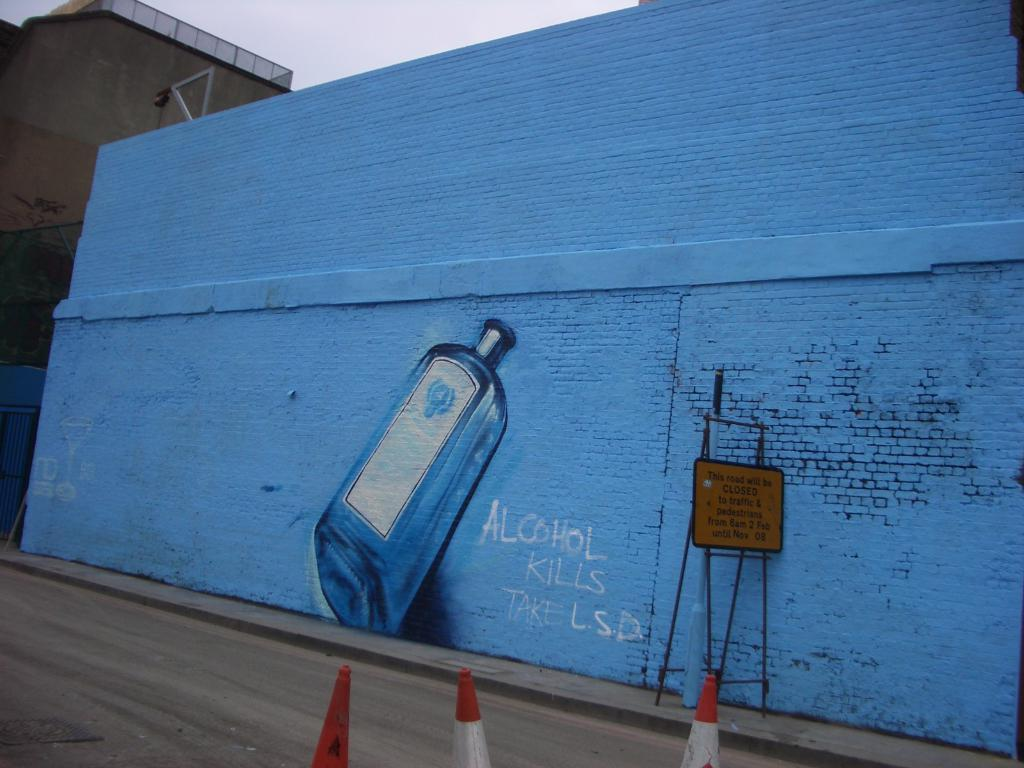<image>
Relay a brief, clear account of the picture shown. A mural that has a bottle of alcohol and words that say Alcohol kills take LSD 